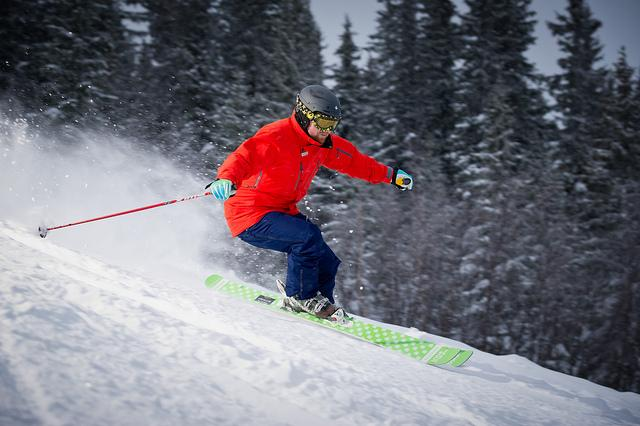What color is the snow jacket worn by the skier? Please explain your reasoning. orange. The skier is clearly visible and the color of the jacket is readily identifiable. 